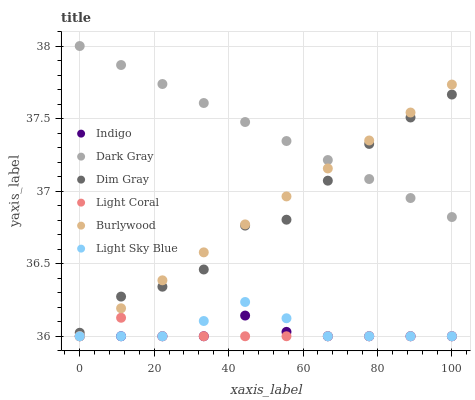Does Light Coral have the minimum area under the curve?
Answer yes or no. Yes. Does Dark Gray have the maximum area under the curve?
Answer yes or no. Yes. Does Dim Gray have the minimum area under the curve?
Answer yes or no. No. Does Dim Gray have the maximum area under the curve?
Answer yes or no. No. Is Burlywood the smoothest?
Answer yes or no. Yes. Is Dim Gray the roughest?
Answer yes or no. Yes. Is Indigo the smoothest?
Answer yes or no. No. Is Indigo the roughest?
Answer yes or no. No. Does Light Coral have the lowest value?
Answer yes or no. Yes. Does Dim Gray have the lowest value?
Answer yes or no. No. Does Dark Gray have the highest value?
Answer yes or no. Yes. Does Dim Gray have the highest value?
Answer yes or no. No. Is Light Sky Blue less than Dark Gray?
Answer yes or no. Yes. Is Dark Gray greater than Light Coral?
Answer yes or no. Yes. Does Dark Gray intersect Dim Gray?
Answer yes or no. Yes. Is Dark Gray less than Dim Gray?
Answer yes or no. No. Is Dark Gray greater than Dim Gray?
Answer yes or no. No. Does Light Sky Blue intersect Dark Gray?
Answer yes or no. No. 